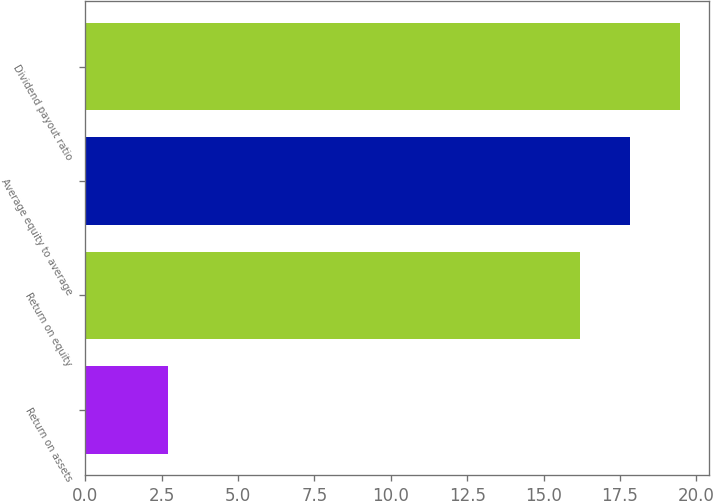<chart> <loc_0><loc_0><loc_500><loc_500><bar_chart><fcel>Return on assets<fcel>Return on equity<fcel>Average equity to average<fcel>Dividend payout ratio<nl><fcel>2.7<fcel>16.2<fcel>17.83<fcel>19.46<nl></chart> 